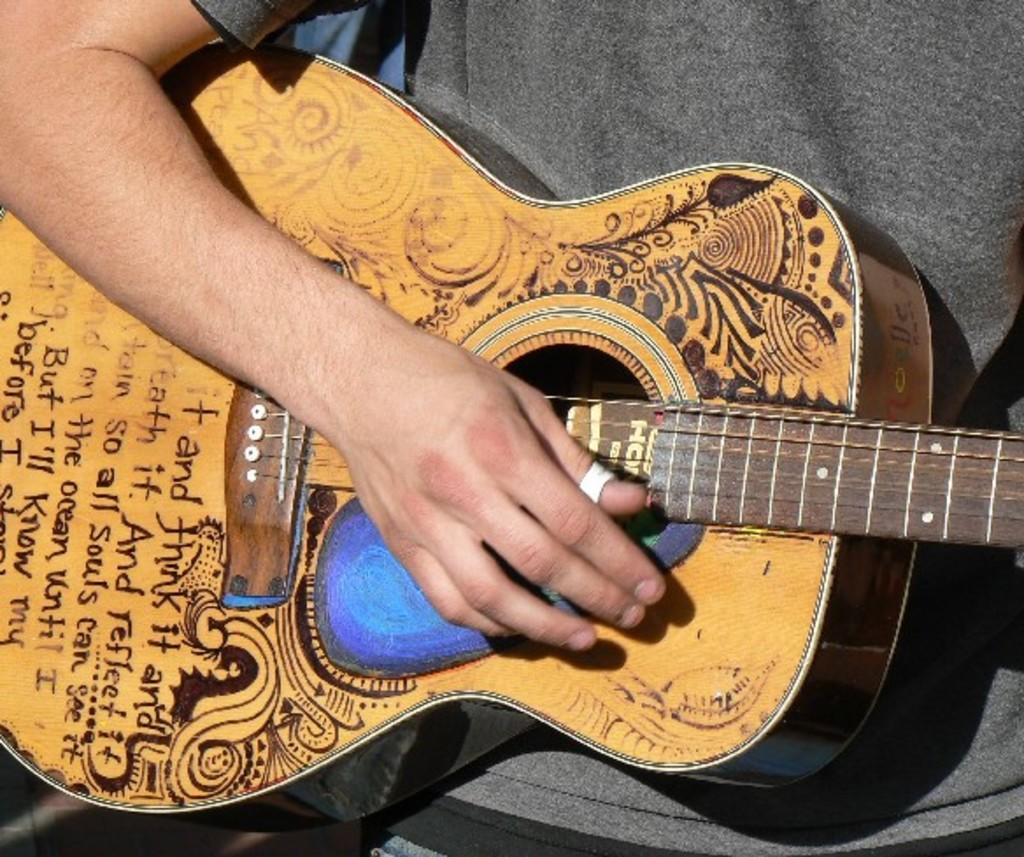Who is the person in the image? There is a man in the image. What is the man holding in the image? The man is holding a guitar. Can you describe the guitar's appearance? The guitar is brown in color and has text on it. What type of crook is visible in the image? There is no crook present in the image. What kind of cord is connected to the guitar in the image? There is no cord connected to the guitar in the image. 